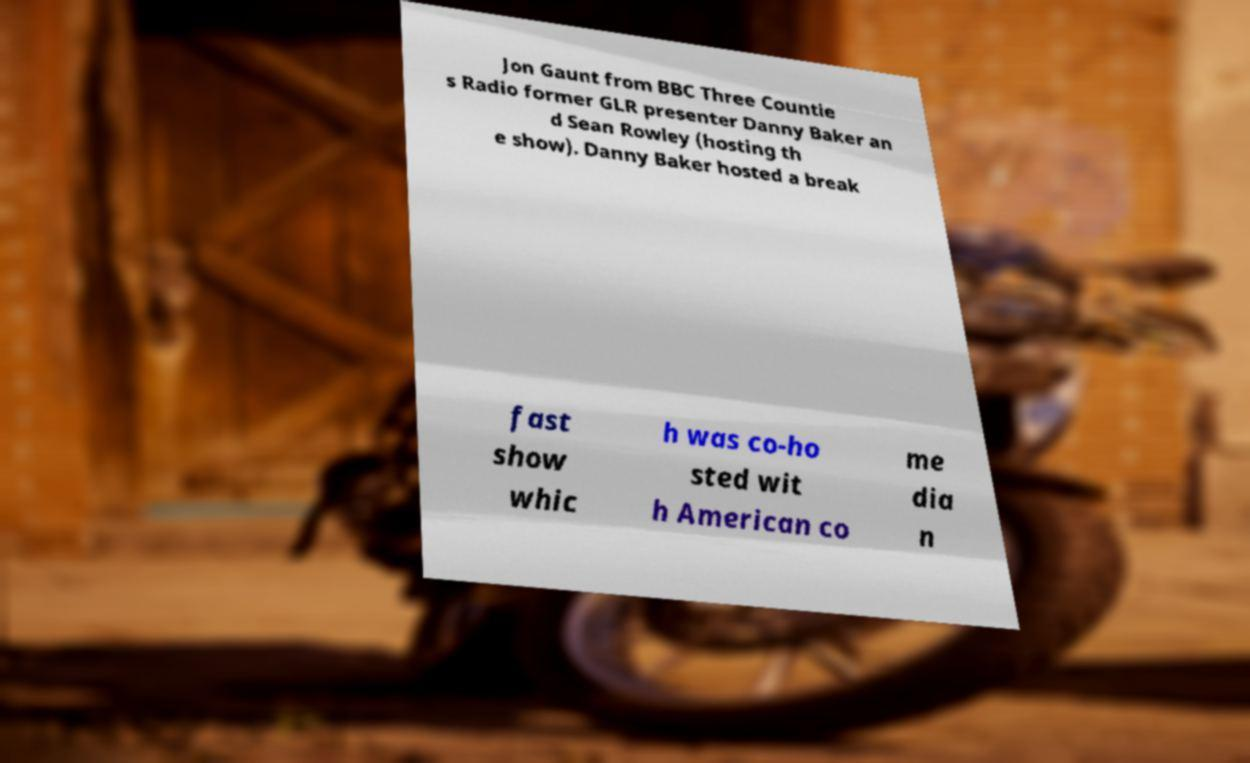Please identify and transcribe the text found in this image. Jon Gaunt from BBC Three Countie s Radio former GLR presenter Danny Baker an d Sean Rowley (hosting th e show). Danny Baker hosted a break fast show whic h was co-ho sted wit h American co me dia n 